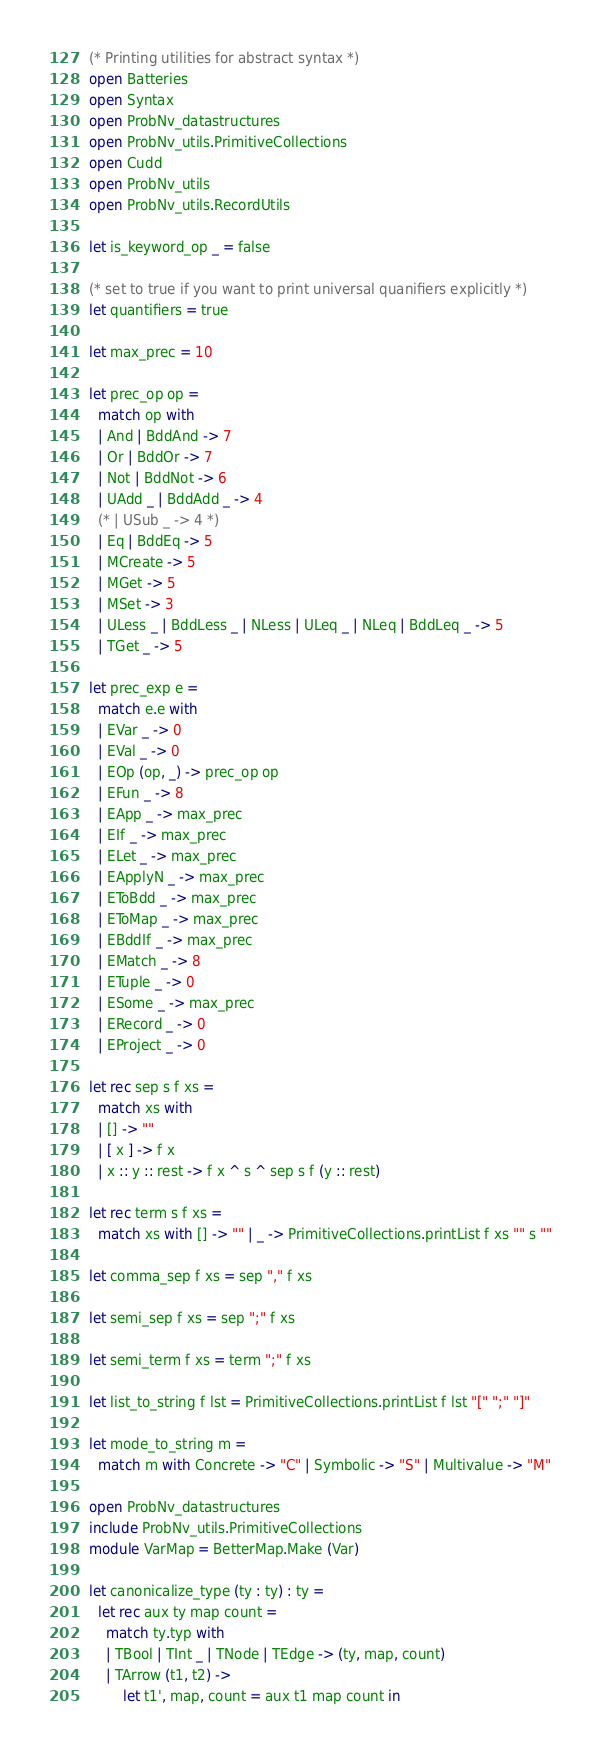<code> <loc_0><loc_0><loc_500><loc_500><_OCaml_>(* Printing utilities for abstract syntax *)
open Batteries
open Syntax
open ProbNv_datastructures
open ProbNv_utils.PrimitiveCollections
open Cudd
open ProbNv_utils
open ProbNv_utils.RecordUtils

let is_keyword_op _ = false

(* set to true if you want to print universal quanifiers explicitly *)
let quantifiers = true

let max_prec = 10

let prec_op op =
  match op with
  | And | BddAnd -> 7
  | Or | BddOr -> 7
  | Not | BddNot -> 6
  | UAdd _ | BddAdd _ -> 4
  (* | USub _ -> 4 *)
  | Eq | BddEq -> 5
  | MCreate -> 5
  | MGet -> 5
  | MSet -> 3
  | ULess _ | BddLess _ | NLess | ULeq _ | NLeq | BddLeq _ -> 5
  | TGet _ -> 5

let prec_exp e =
  match e.e with
  | EVar _ -> 0
  | EVal _ -> 0
  | EOp (op, _) -> prec_op op
  | EFun _ -> 8
  | EApp _ -> max_prec
  | EIf _ -> max_prec
  | ELet _ -> max_prec
  | EApplyN _ -> max_prec
  | EToBdd _ -> max_prec
  | EToMap _ -> max_prec
  | EBddIf _ -> max_prec
  | EMatch _ -> 8
  | ETuple _ -> 0
  | ESome _ -> max_prec
  | ERecord _ -> 0
  | EProject _ -> 0

let rec sep s f xs =
  match xs with
  | [] -> ""
  | [ x ] -> f x
  | x :: y :: rest -> f x ^ s ^ sep s f (y :: rest)

let rec term s f xs =
  match xs with [] -> "" | _ -> PrimitiveCollections.printList f xs "" s ""

let comma_sep f xs = sep "," f xs

let semi_sep f xs = sep ";" f xs

let semi_term f xs = term ";" f xs

let list_to_string f lst = PrimitiveCollections.printList f lst "[" ";" "]"

let mode_to_string m =
  match m with Concrete -> "C" | Symbolic -> "S" | Multivalue -> "M"

open ProbNv_datastructures
include ProbNv_utils.PrimitiveCollections
module VarMap = BetterMap.Make (Var)

let canonicalize_type (ty : ty) : ty =
  let rec aux ty map count =
    match ty.typ with
    | TBool | TInt _ | TNode | TEdge -> (ty, map, count)
    | TArrow (t1, t2) ->
        let t1', map, count = aux t1 map count in</code> 